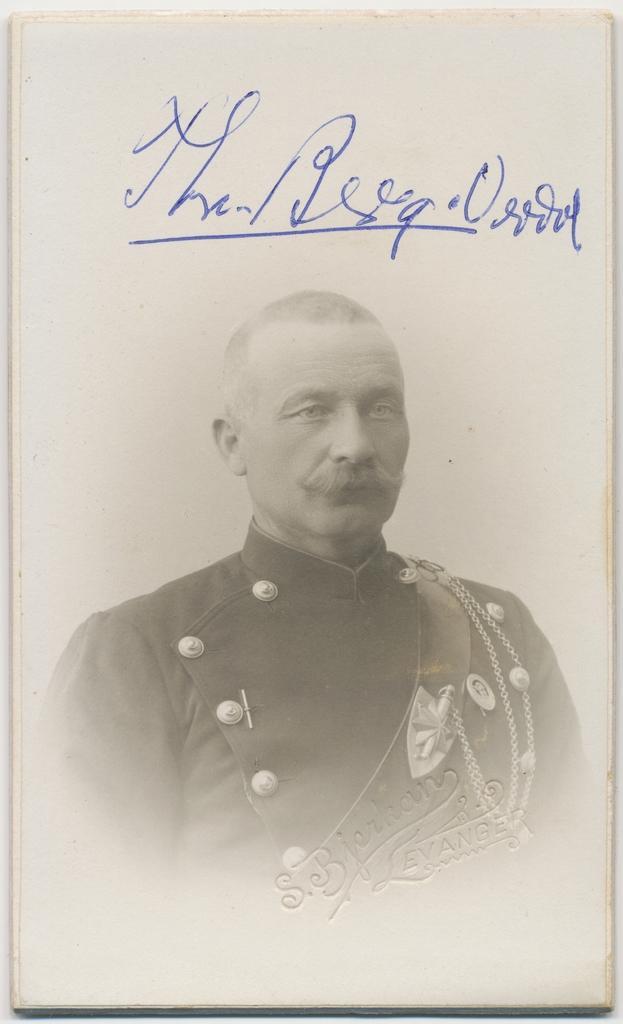Could you give a brief overview of what you see in this image? In the image there is a photograph of a man. And there is something written on it. 